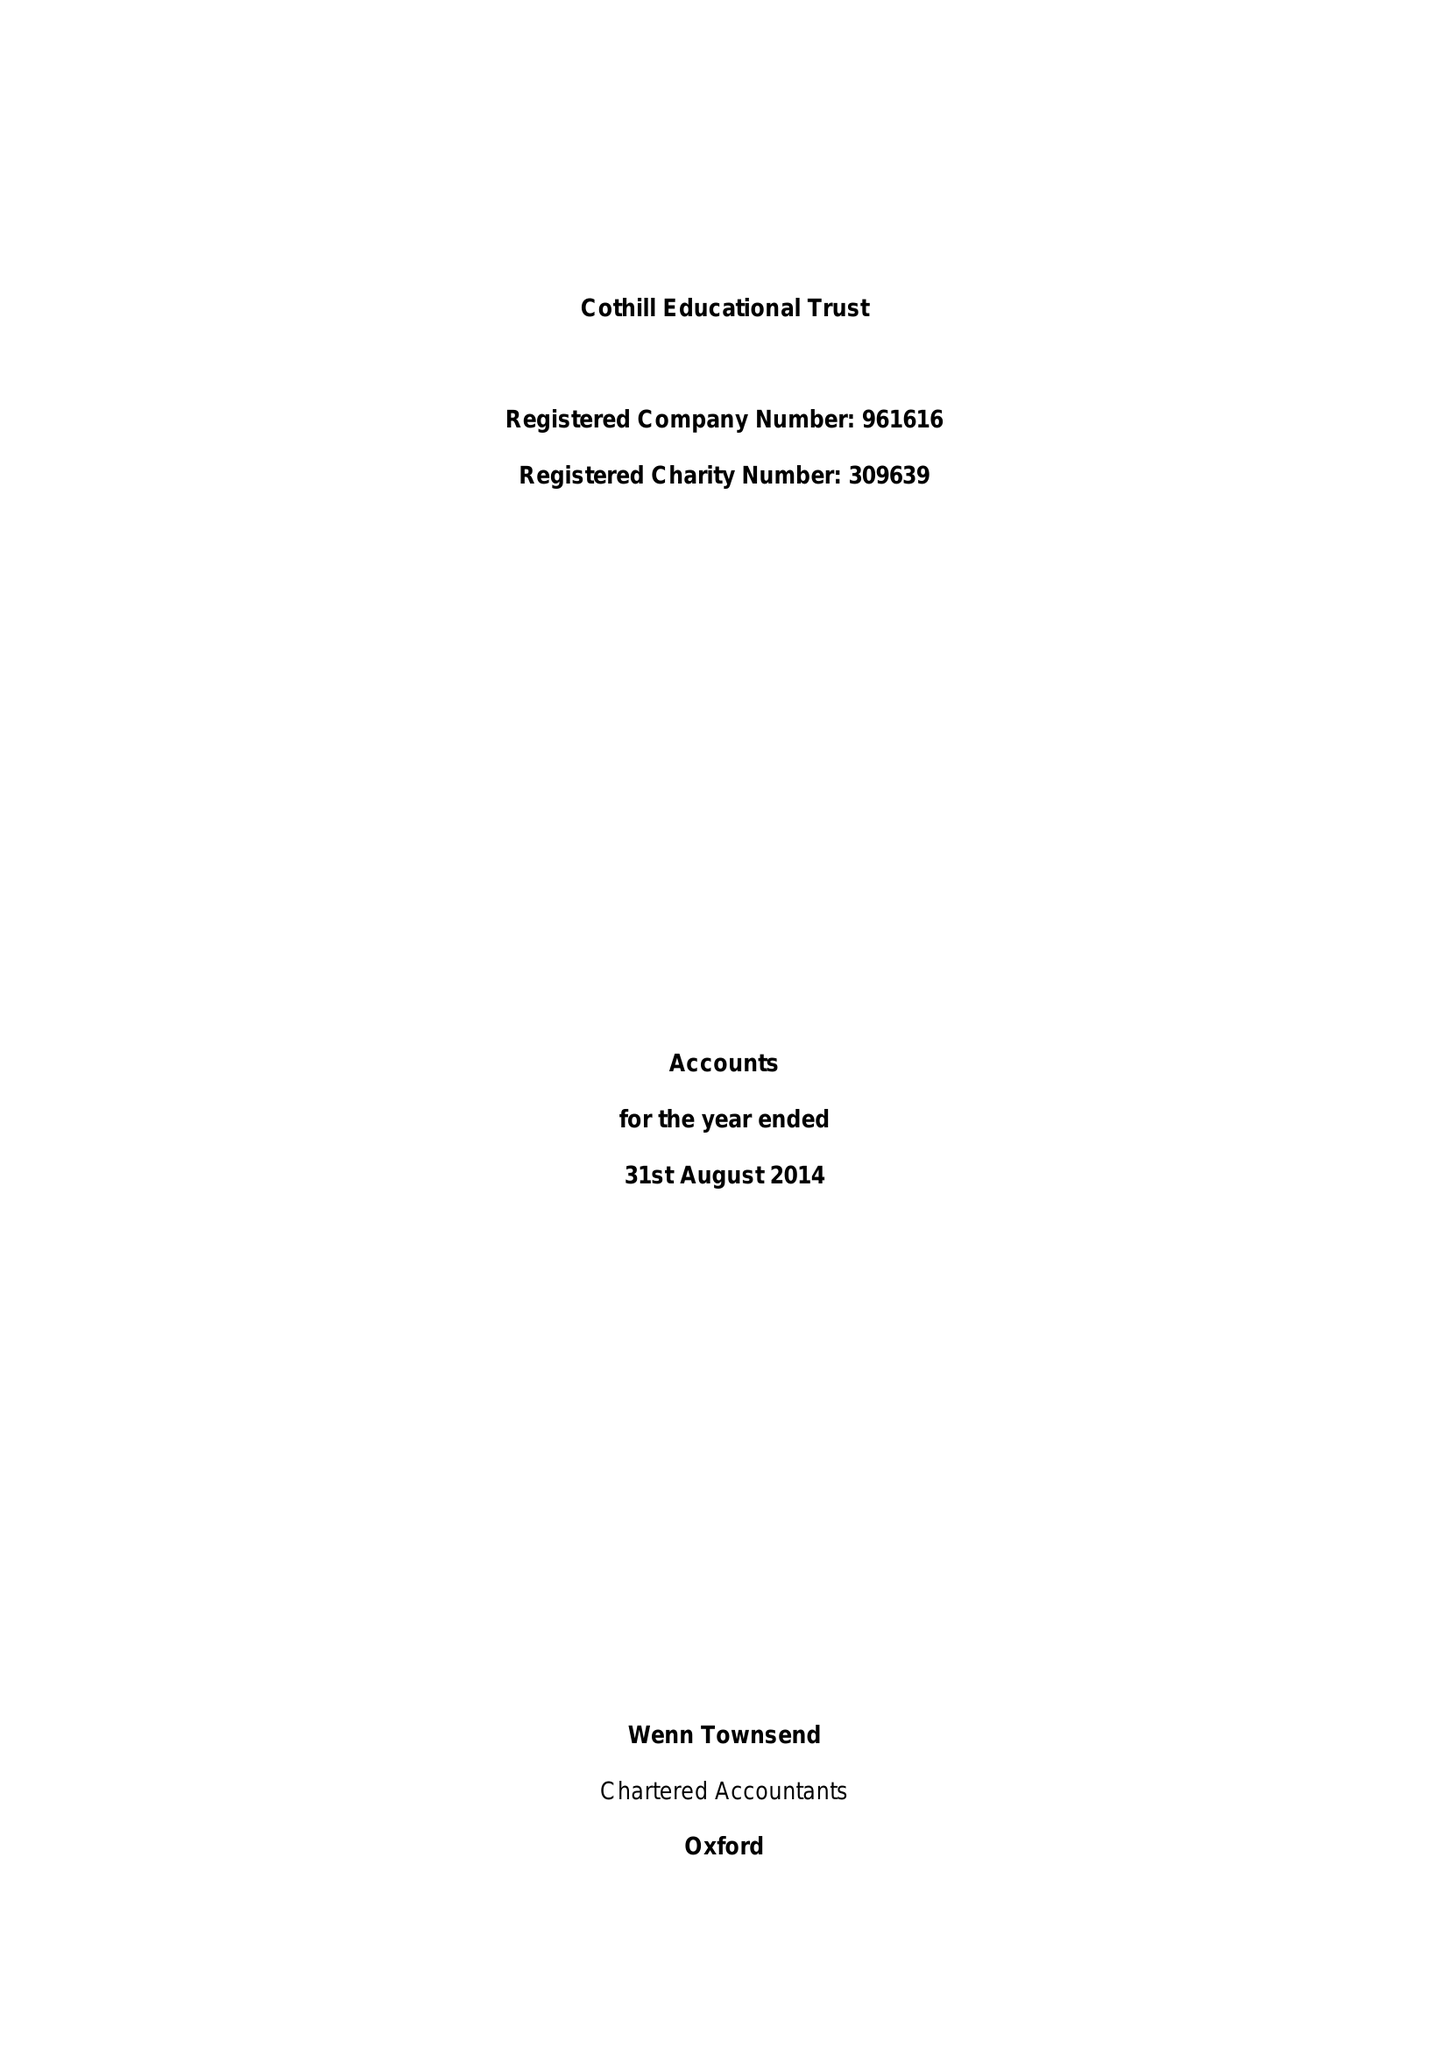What is the value for the address__street_line?
Answer the question using a single word or phrase. None 